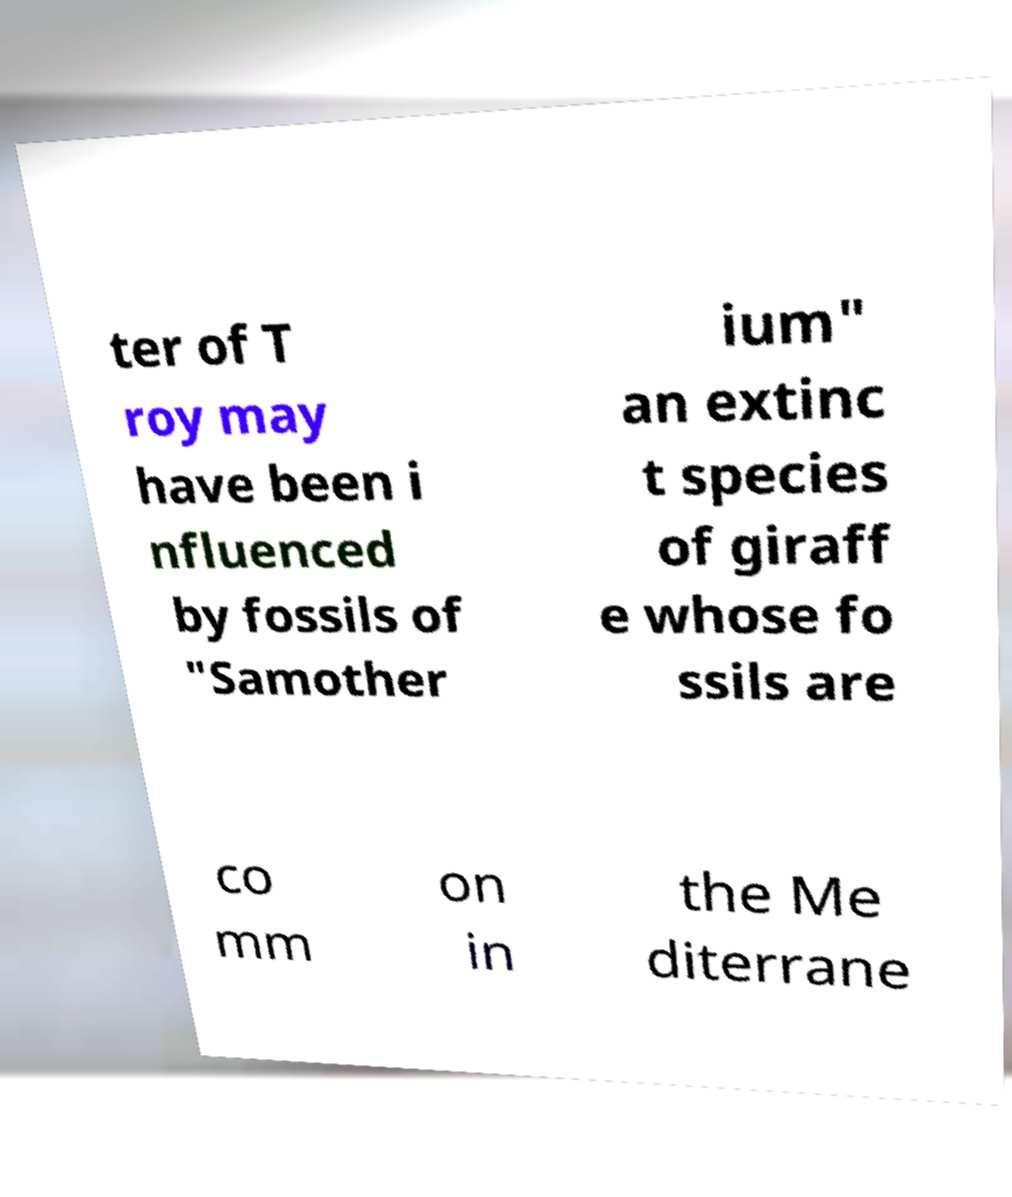Could you extract and type out the text from this image? ter of T roy may have been i nfluenced by fossils of "Samother ium" an extinc t species of giraff e whose fo ssils are co mm on in the Me diterrane 